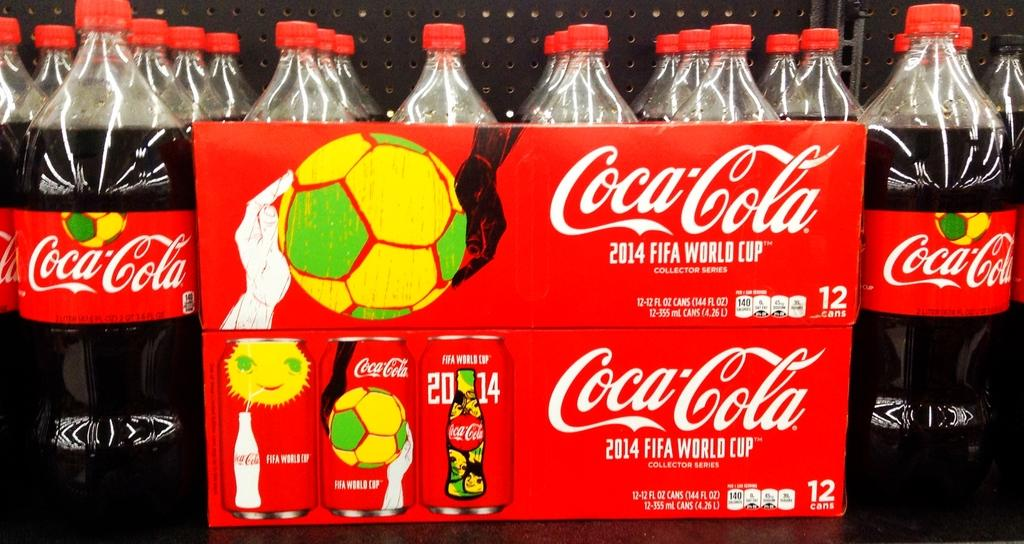What type of beverage bottles are in the image? There are coca cola bottles in the image. How are the bottles arranged in the image? The bottles are placed in a rack. What else related to coca cola can be seen in the image? There is a poster of coca cola in the image. What is depicted on the coca cola poster? The poster features balls and a tin. What type of vegetable is being used as a bat in the image? There is no vegetable or bat present in the image; it features coca cola bottles, a rack, and a poster with balls and a tin. 